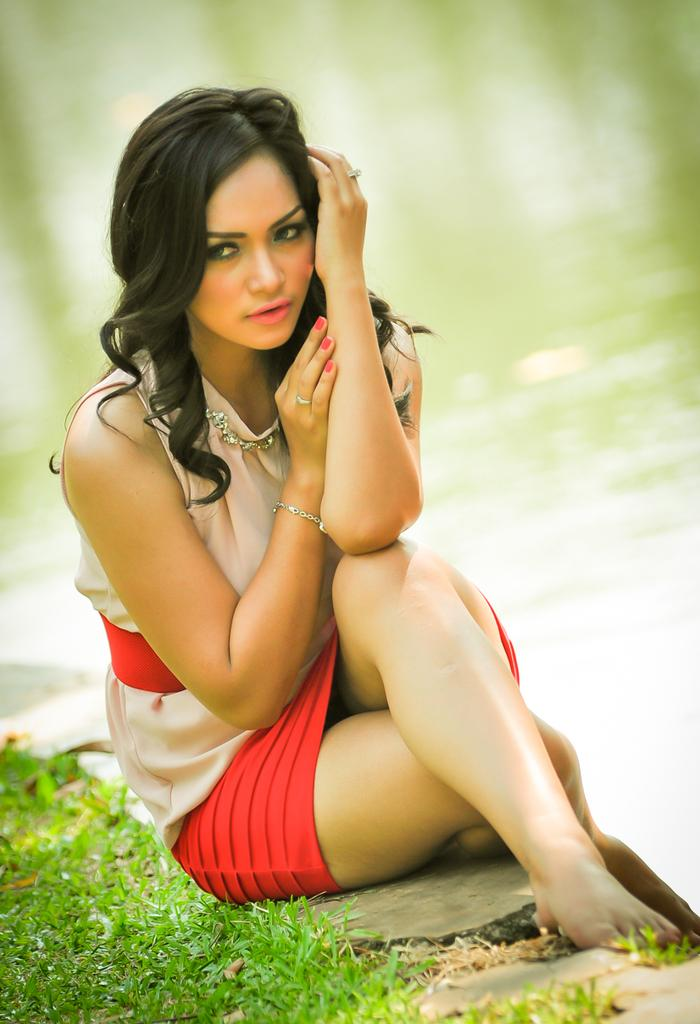What is the person in the image wearing? There is a person with a dress in the image. What type of natural environment is visible on the left side of the image? There is grass on the left side of the image. What body of water can be seen in the image? There is water visible in the image. How would you describe the background of the image? The background of the image appears blurred. How many sisters are present in the image? There is no mention of sisters in the image, so it cannot be determined from the provided facts. 